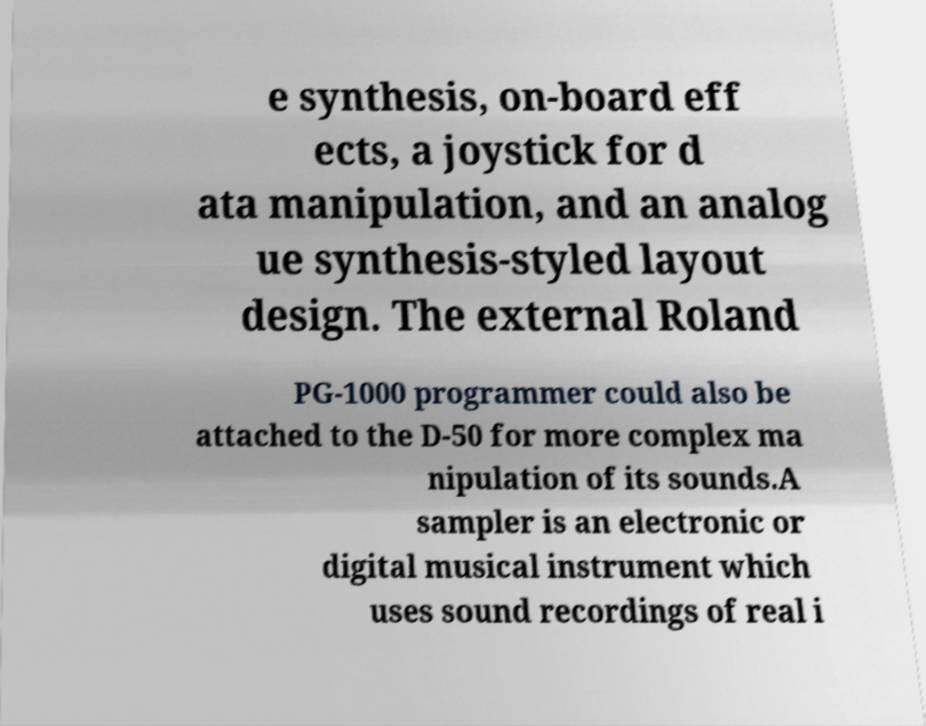There's text embedded in this image that I need extracted. Can you transcribe it verbatim? e synthesis, on-board eff ects, a joystick for d ata manipulation, and an analog ue synthesis-styled layout design. The external Roland PG-1000 programmer could also be attached to the D-50 for more complex ma nipulation of its sounds.A sampler is an electronic or digital musical instrument which uses sound recordings of real i 